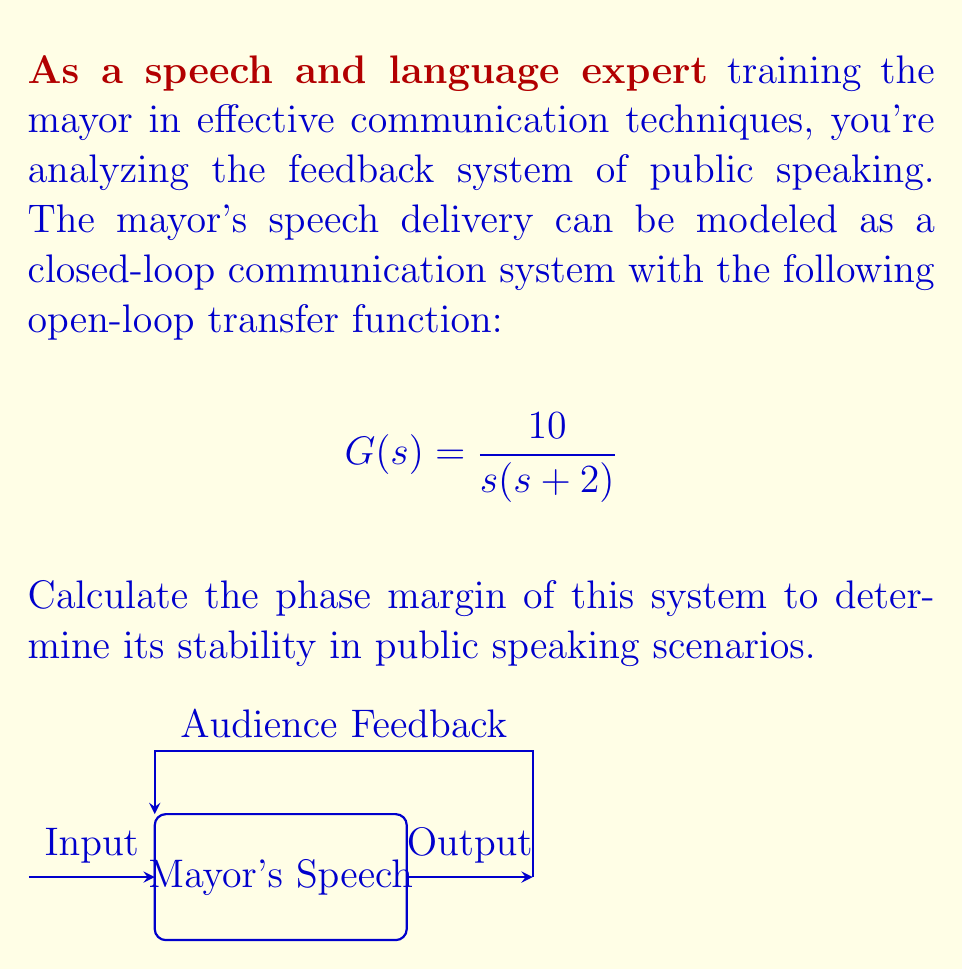What is the answer to this math problem? To calculate the phase margin, we need to follow these steps:

1) First, find the gain crossover frequency $\omega_c$ where the magnitude of $G(j\omega)$ is 1 (0 dB).

2) The open-loop transfer function is $G(s) = \frac{10}{s(s+2)}$

3) Substitute $s$ with $j\omega$:
   $$G(j\omega) = \frac{10}{j\omega(j\omega+2)}$$

4) Calculate the magnitude:
   $$|G(j\omega)| = \frac{10}{\sqrt{\omega^2(\omega^2+4)}}$$

5) Set this equal to 1 and solve for $\omega_c$:
   $$\frac{10}{\sqrt{\omega_c^2(\omega_c^2+4)}} = 1$$
   $$10^2 = \omega_c^2(\omega_c^2+4)$$
   $$100 = \omega_c^4 + 4\omega_c^2$$
   $$\omega_c^4 + 4\omega_c^2 - 100 = 0$$

6) This is a quadratic in $\omega_c^2$. Solving it:
   $$\omega_c^2 = \frac{-4 \pm \sqrt{16 + 400}}{2} = \frac{-4 \pm \sqrt{416}}{2}$$
   $$\omega_c^2 \approx 8.8541$$
   $$\omega_c \approx 2.9757 \text{ rad/s}$$

7) Now, calculate the phase of $G(j\omega_c)$:
   $$\angle G(j\omega_c) = -90° - \tan^{-1}(\frac{\omega_c}{2})$$
   $$\angle G(j\omega_c) = -90° - \tan^{-1}(\frac{2.9757}{2})$$
   $$\angle G(j\omega_c) \approx -146.15°$$

8) The phase margin is:
   $$\text{PM} = 180° + \angle G(j\omega_c)$$
   $$\text{PM} \approx 180° + (-146.15°) \approx 33.85°$$
Answer: 33.85° 